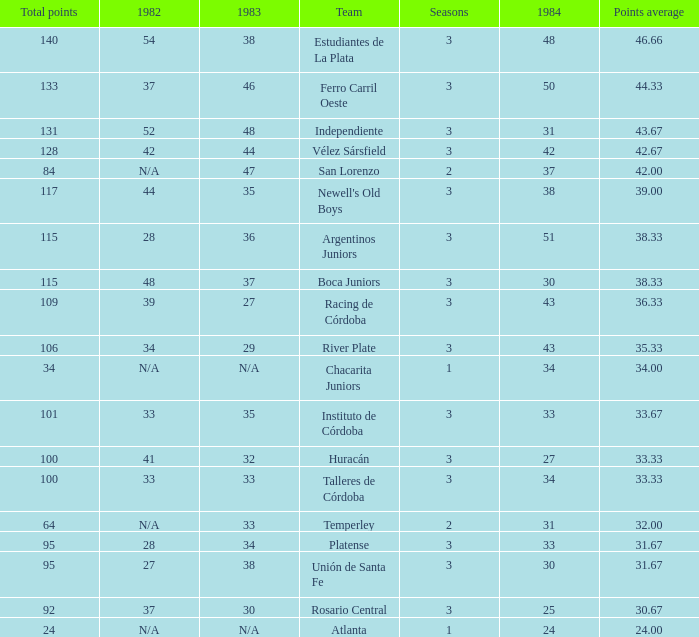Can you give me this table as a dict? {'header': ['Total points', '1982', '1983', 'Team', 'Seasons', '1984', 'Points average'], 'rows': [['140', '54', '38', 'Estudiantes de La Plata', '3', '48', '46.66'], ['133', '37', '46', 'Ferro Carril Oeste', '3', '50', '44.33'], ['131', '52', '48', 'Independiente', '3', '31', '43.67'], ['128', '42', '44', 'Vélez Sársfield', '3', '42', '42.67'], ['84', 'N/A', '47', 'San Lorenzo', '2', '37', '42.00'], ['117', '44', '35', "Newell's Old Boys", '3', '38', '39.00'], ['115', '28', '36', 'Argentinos Juniors', '3', '51', '38.33'], ['115', '48', '37', 'Boca Juniors', '3', '30', '38.33'], ['109', '39', '27', 'Racing de Córdoba', '3', '43', '36.33'], ['106', '34', '29', 'River Plate', '3', '43', '35.33'], ['34', 'N/A', 'N/A', 'Chacarita Juniors', '1', '34', '34.00'], ['101', '33', '35', 'Instituto de Córdoba', '3', '33', '33.67'], ['100', '41', '32', 'Huracán', '3', '27', '33.33'], ['100', '33', '33', 'Talleres de Córdoba', '3', '34', '33.33'], ['64', 'N/A', '33', 'Temperley', '2', '31', '32.00'], ['95', '28', '34', 'Platense', '3', '33', '31.67'], ['95', '27', '38', 'Unión de Santa Fe', '3', '30', '31.67'], ['92', '37', '30', 'Rosario Central', '3', '25', '30.67'], ['24', 'N/A', 'N/A', 'Atlanta', '1', '24', '24.00']]} What team had 3 seasons and fewer than 27 in 1984? Rosario Central. 